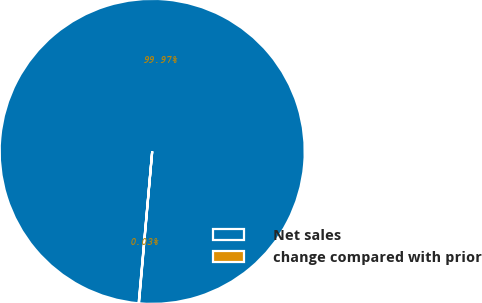<chart> <loc_0><loc_0><loc_500><loc_500><pie_chart><fcel>Net sales<fcel>change compared with prior<nl><fcel>99.97%<fcel>0.03%<nl></chart> 